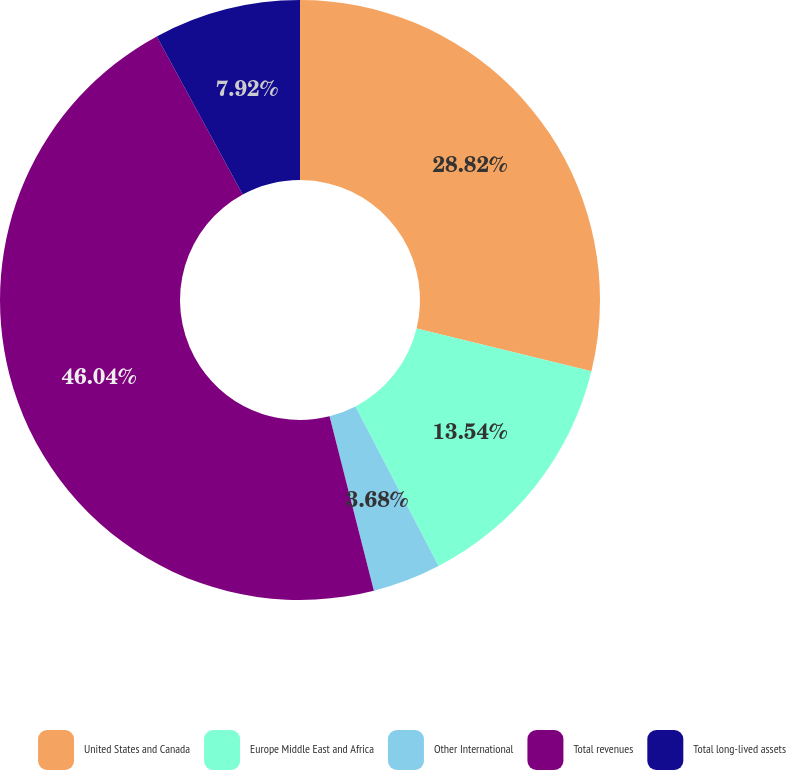Convert chart. <chart><loc_0><loc_0><loc_500><loc_500><pie_chart><fcel>United States and Canada<fcel>Europe Middle East and Africa<fcel>Other International<fcel>Total revenues<fcel>Total long-lived assets<nl><fcel>28.82%<fcel>13.54%<fcel>3.68%<fcel>46.04%<fcel>7.92%<nl></chart> 